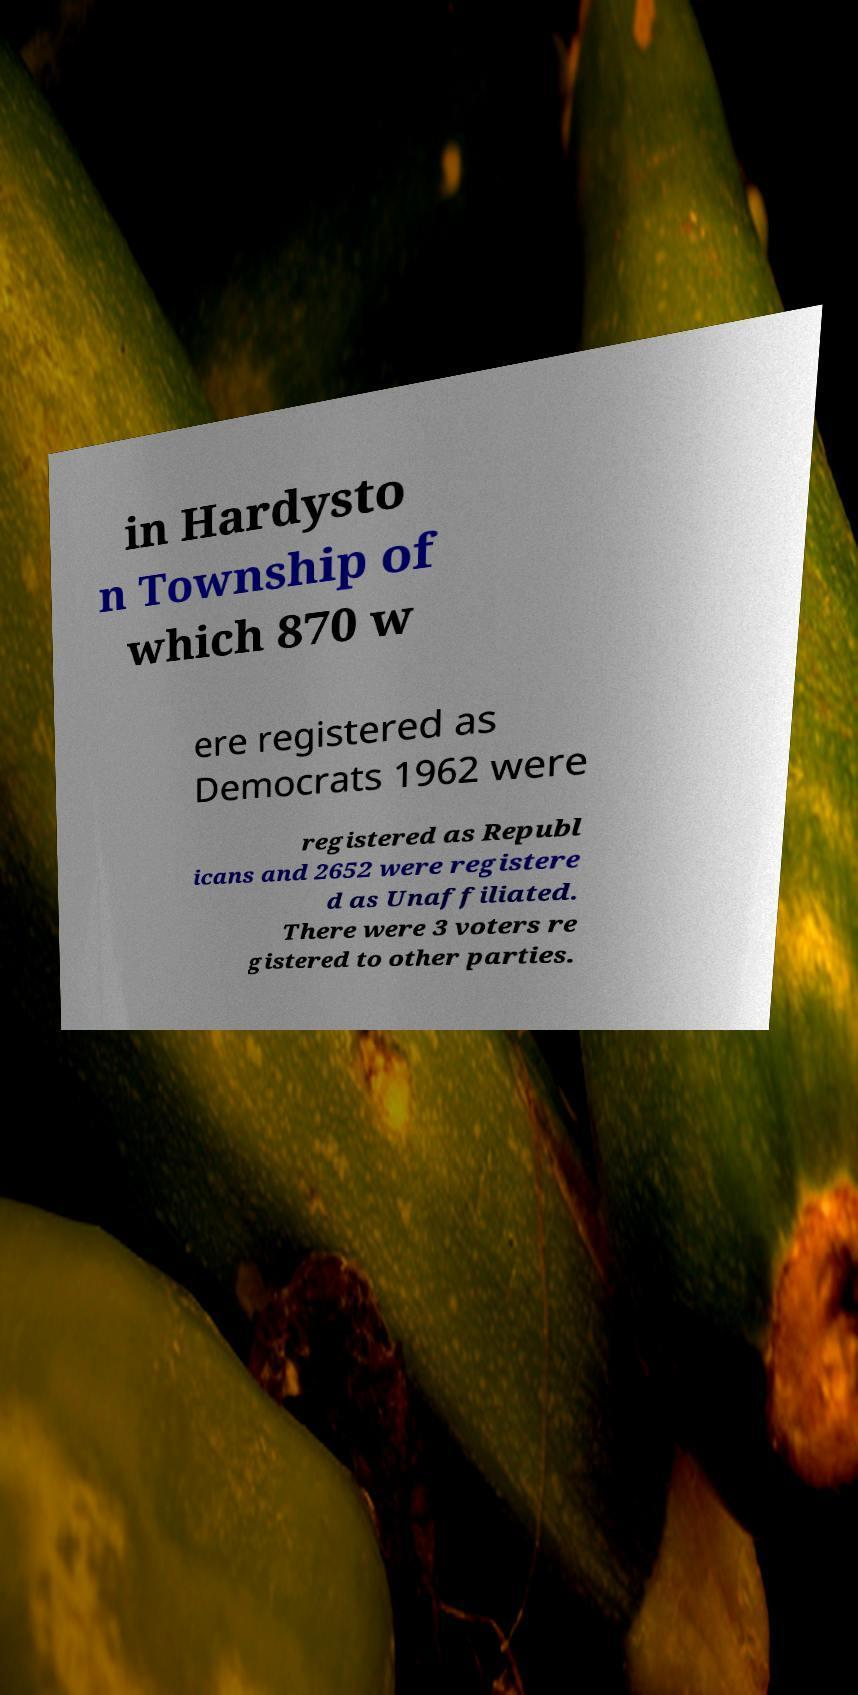There's text embedded in this image that I need extracted. Can you transcribe it verbatim? in Hardysto n Township of which 870 w ere registered as Democrats 1962 were registered as Republ icans and 2652 were registere d as Unaffiliated. There were 3 voters re gistered to other parties. 